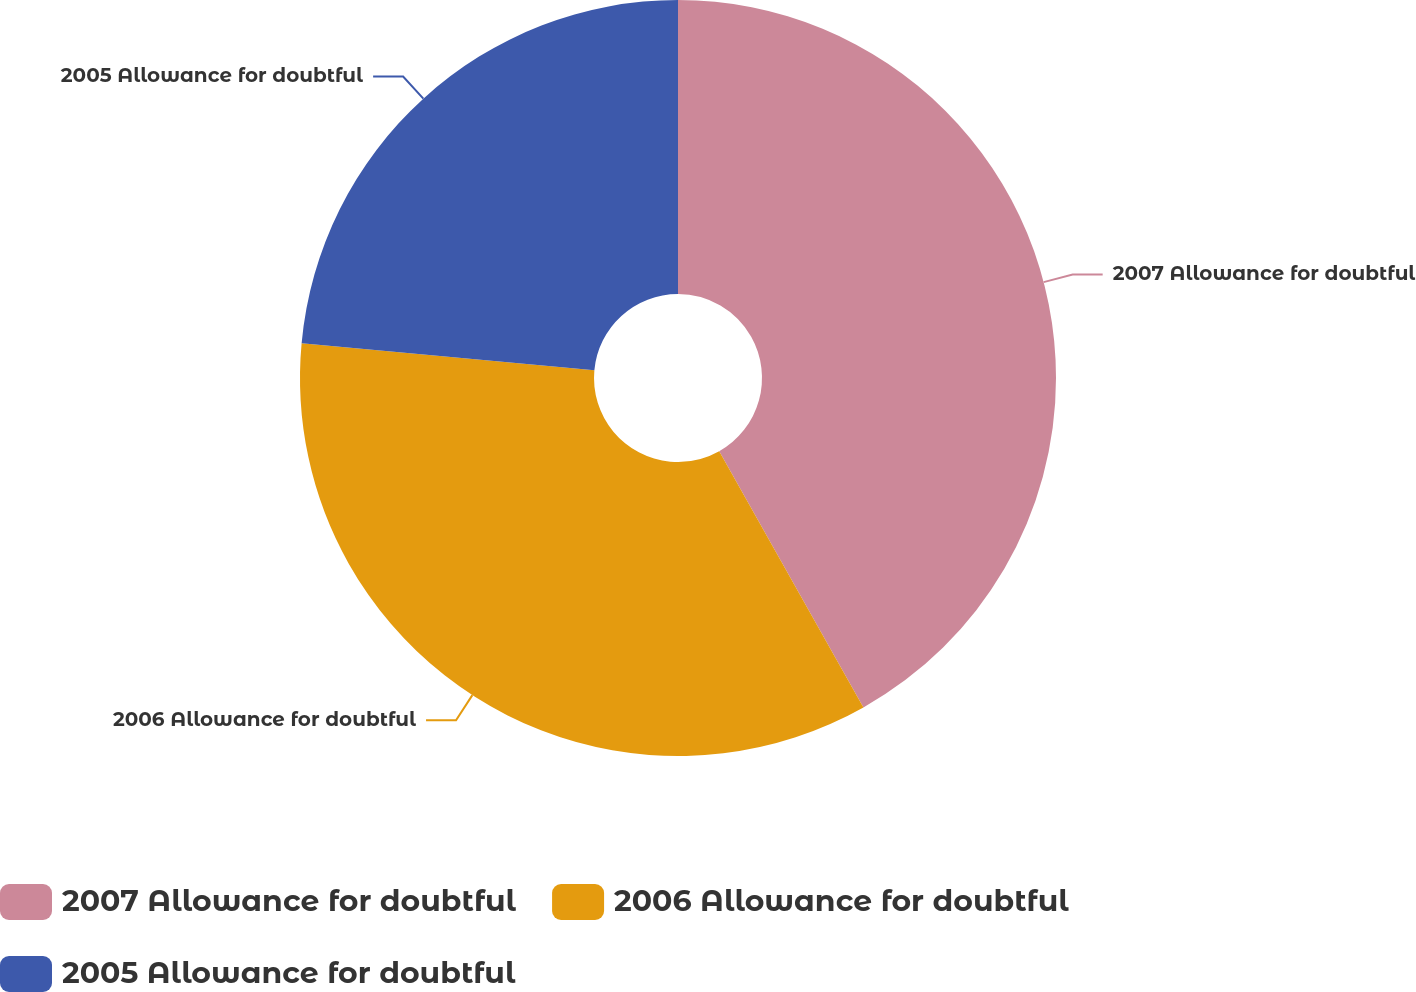Convert chart. <chart><loc_0><loc_0><loc_500><loc_500><pie_chart><fcel>2007 Allowance for doubtful<fcel>2006 Allowance for doubtful<fcel>2005 Allowance for doubtful<nl><fcel>41.84%<fcel>34.63%<fcel>23.53%<nl></chart> 